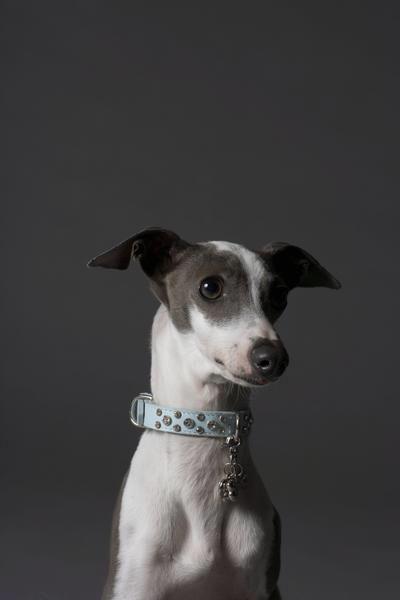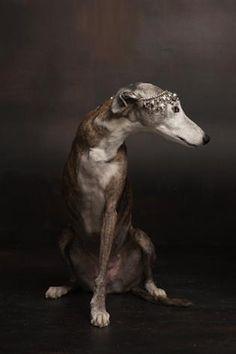The first image is the image on the left, the second image is the image on the right. For the images shown, is this caption "A dog with a collar is looking at the camera in the image on the left." true? Answer yes or no. No. The first image is the image on the left, the second image is the image on the right. For the images displayed, is the sentence "An image contains a thin dark dog that is looking towards the right." factually correct? Answer yes or no. Yes. 